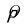<formula> <loc_0><loc_0><loc_500><loc_500>\hat { \rho }</formula> 